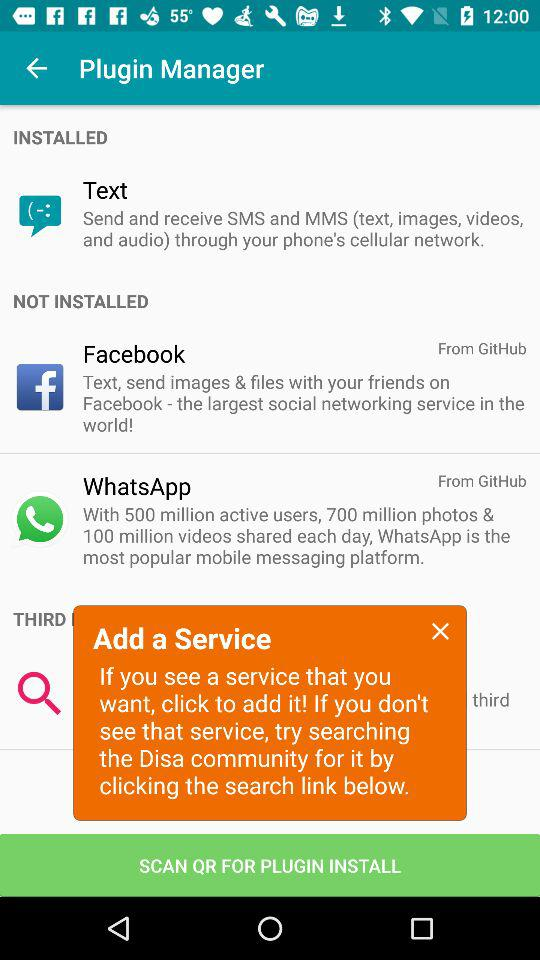How many photos and videos are shared each day in "WhatsApp"? There are 700 million photos and 100 million videos shared each day. 